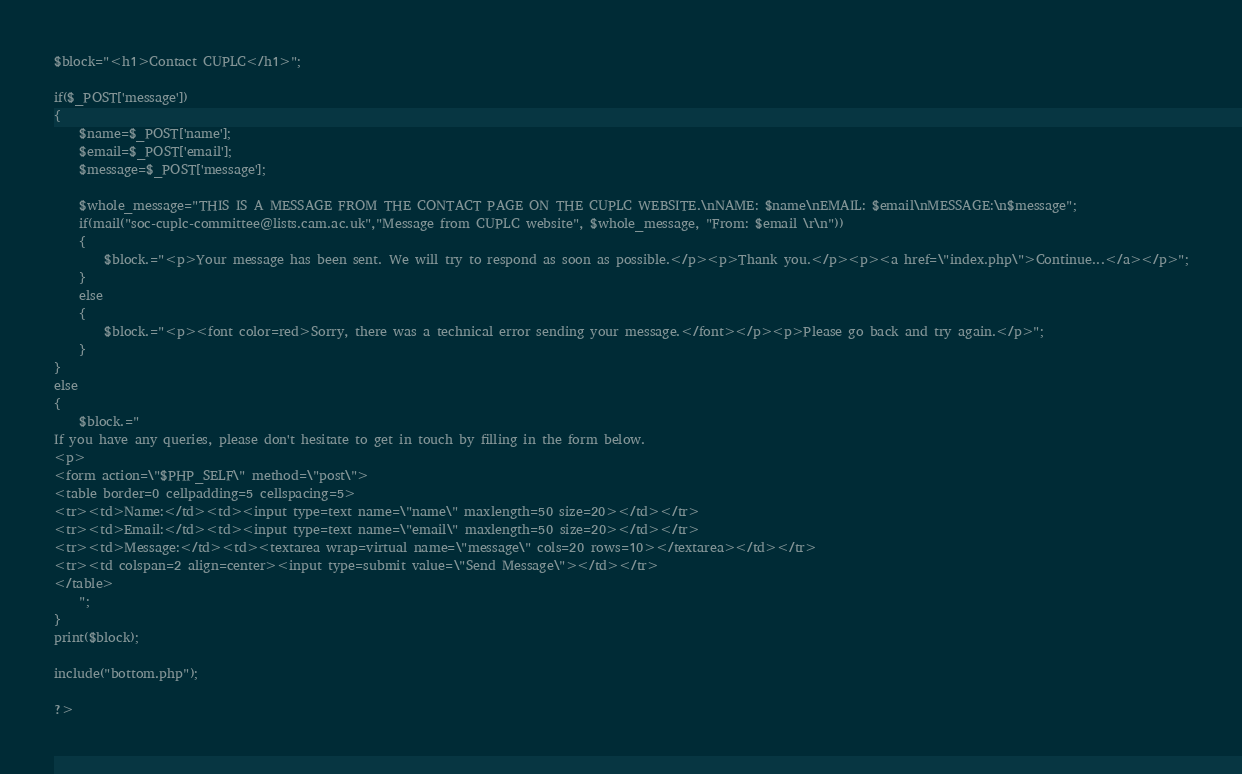Convert code to text. <code><loc_0><loc_0><loc_500><loc_500><_PHP_>$block="<h1>Contact CUPLC</h1>";

if($_POST['message'])
{
	$name=$_POST['name'];
	$email=$_POST['email'];
	$message=$_POST['message'];

	$whole_message="THIS IS A MESSAGE FROM THE CONTACT PAGE ON THE CUPLC WEBSITE.\nNAME: $name\nEMAIL: $email\nMESSAGE:\n$message";
	if(mail("soc-cuplc-committee@lists.cam.ac.uk","Message from CUPLC website", $whole_message, "From: $email \r\n"))
	{
		$block.="<p>Your message has been sent. We will try to respond as soon as possible.</p><p>Thank you.</p><p><a href=\"index.php\">Continue...</a></p>";
	}
	else
	{
		$block.="<p><font color=red>Sorry, there was a technical error sending your message.</font></p><p>Please go back and try again.</p>";
	}
}
else
{
	$block.="
If you have any queries, please don't hesitate to get in touch by filling in the form below.
<p>
<form action=\"$PHP_SELF\" method=\"post\">
<table border=0 cellpadding=5 cellspacing=5>
<tr><td>Name:</td><td><input type=text name=\"name\" maxlength=50 size=20></td></tr>
<tr><td>Email:</td><td><input type=text name=\"email\" maxlength=50 size=20></td></tr>
<tr><td>Message:</td><td><textarea wrap=virtual name=\"message\" cols=20 rows=10></textarea></td></tr>
<tr><td colspan=2 align=center><input type=submit value=\"Send Message\"></td></tr>
</table>
	";
}
print($block);

include("bottom.php");

?>
</code> 